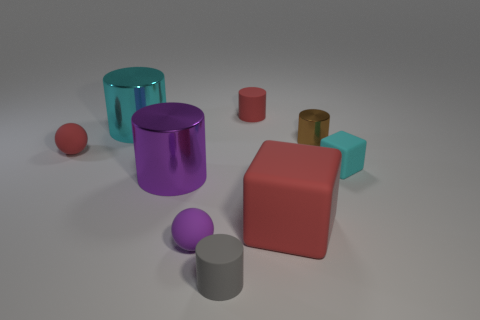There is a purple ball; are there any small gray rubber cylinders behind it?
Your response must be concise. No. Is the number of things right of the red rubber cylinder greater than the number of things that are in front of the big red matte object?
Make the answer very short. Yes. What size is the gray object that is the same shape as the big cyan thing?
Offer a terse response. Small. What number of balls are small metal objects or red rubber objects?
Offer a very short reply. 1. There is a cylinder that is the same color as the big matte object; what material is it?
Your answer should be very brief. Rubber. Are there fewer tiny brown metallic cylinders in front of the gray cylinder than tiny cyan rubber cubes behind the tiny cyan matte cube?
Keep it short and to the point. No. What number of things are red matte things that are in front of the brown thing or large cyan things?
Your answer should be compact. 3. What is the shape of the red matte object behind the red matte thing that is left of the gray thing?
Ensure brevity in your answer.  Cylinder. Is there a brown cylinder of the same size as the gray thing?
Your response must be concise. Yes. Is the number of shiny things greater than the number of small red cylinders?
Ensure brevity in your answer.  Yes. 